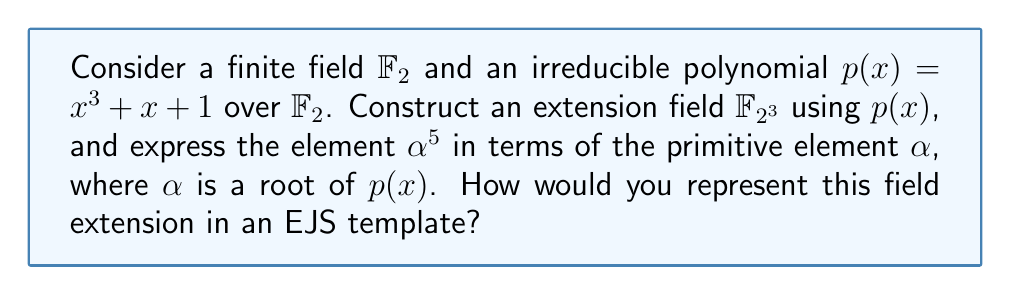Help me with this question. 1. First, we construct the extension field $\mathbb{F}_{2^3}$ using $p(x) = x^3 + x + 1$ over $\mathbb{F}_2$:
   $\mathbb{F}_{2^3} = \mathbb{F}_2[x]/(p(x))$

2. The elements of $\mathbb{F}_{2^3}$ are of the form $a_0 + a_1\alpha + a_2\alpha^2$, where $a_i \in \mathbb{F}_2$ and $\alpha$ is a root of $p(x)$.

3. To express $\alpha^5$ in terms of $\alpha$, we use the fact that $\alpha^3 = \alpha + 1$ (from $p(\alpha) = 0$):
   $\alpha^3 = \alpha + 1$
   $\alpha^4 = \alpha(\alpha + 1) = \alpha^2 + \alpha$
   $\alpha^5 = \alpha(\alpha^2 + \alpha) = \alpha^3 + \alpha^2 = (\alpha + 1) + \alpha^2 = \alpha^2 + \alpha + 1$

4. To represent this field extension in an EJS template, we can create an object or array to store the coefficients of the polynomial representation:

```ejs
<%
const alpha5 = {
  coefficients: [1, 1, 1],
  base: 2,
  degree: 3
};
%>

<p>α^5 = <%= alpha5.coefficients.map((c, i) => c ? `α^${i}` : '').filter(Boolean).join(' + ') %></p>
```

This EJS code creates an object `alpha5` representing $\alpha^5 = \alpha^2 + \alpha + 1$ in $\mathbb{F}_{2^3}$, and then renders it as a string.
Answer: $\alpha^5 = \alpha^2 + \alpha + 1$ in $\mathbb{F}_{2^3}$ 